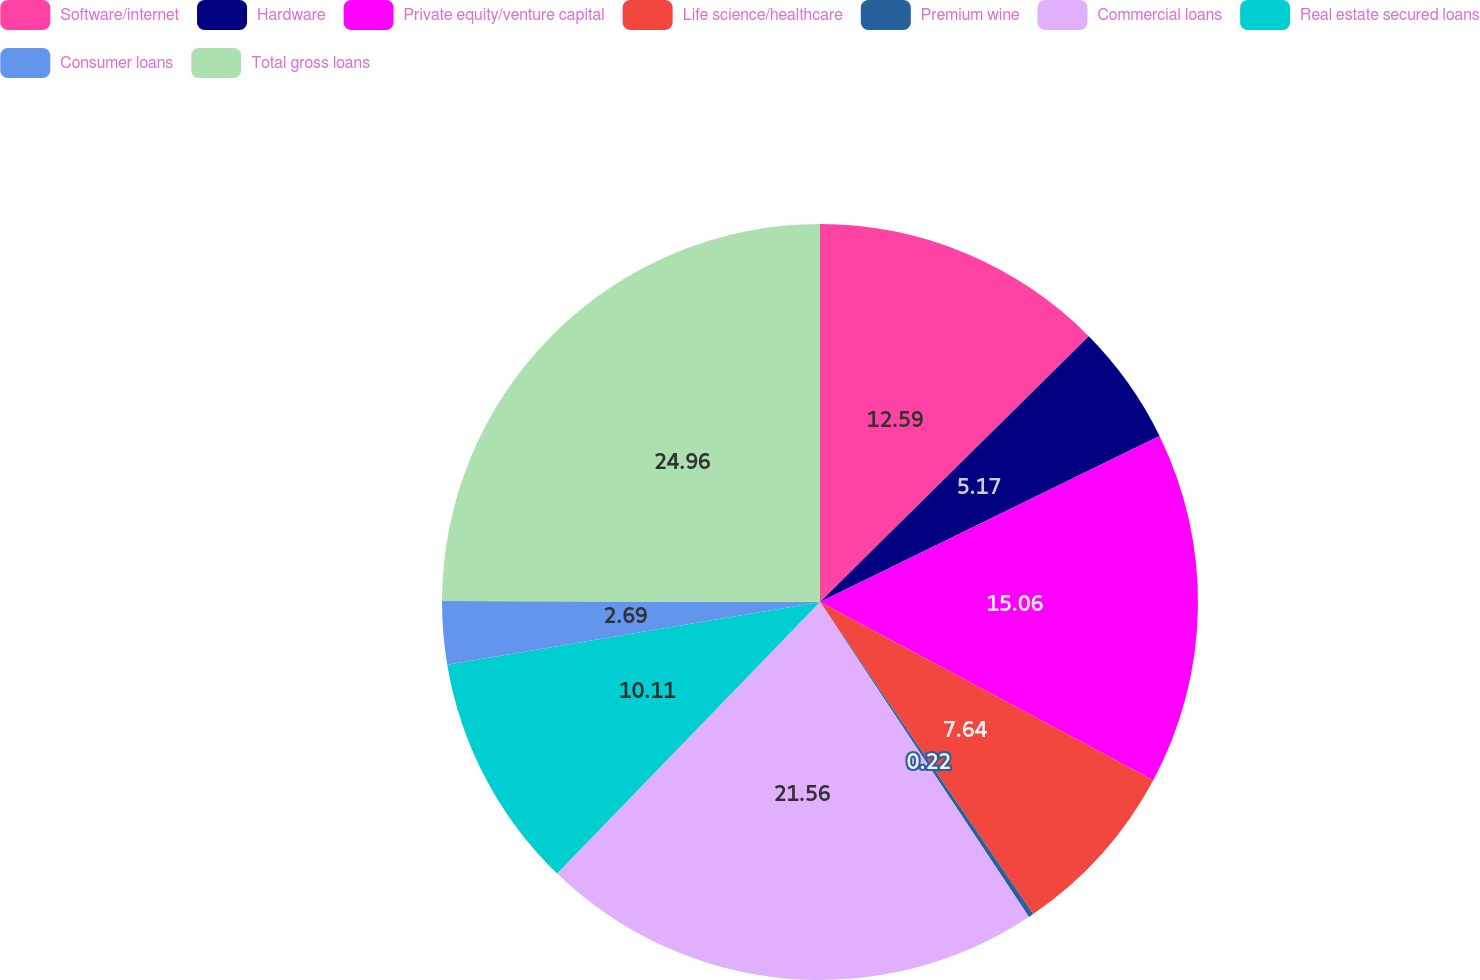Convert chart to OTSL. <chart><loc_0><loc_0><loc_500><loc_500><pie_chart><fcel>Software/internet<fcel>Hardware<fcel>Private equity/venture capital<fcel>Life science/healthcare<fcel>Premium wine<fcel>Commercial loans<fcel>Real estate secured loans<fcel>Consumer loans<fcel>Total gross loans<nl><fcel>12.59%<fcel>5.17%<fcel>15.06%<fcel>7.64%<fcel>0.22%<fcel>21.56%<fcel>10.11%<fcel>2.69%<fcel>24.96%<nl></chart> 